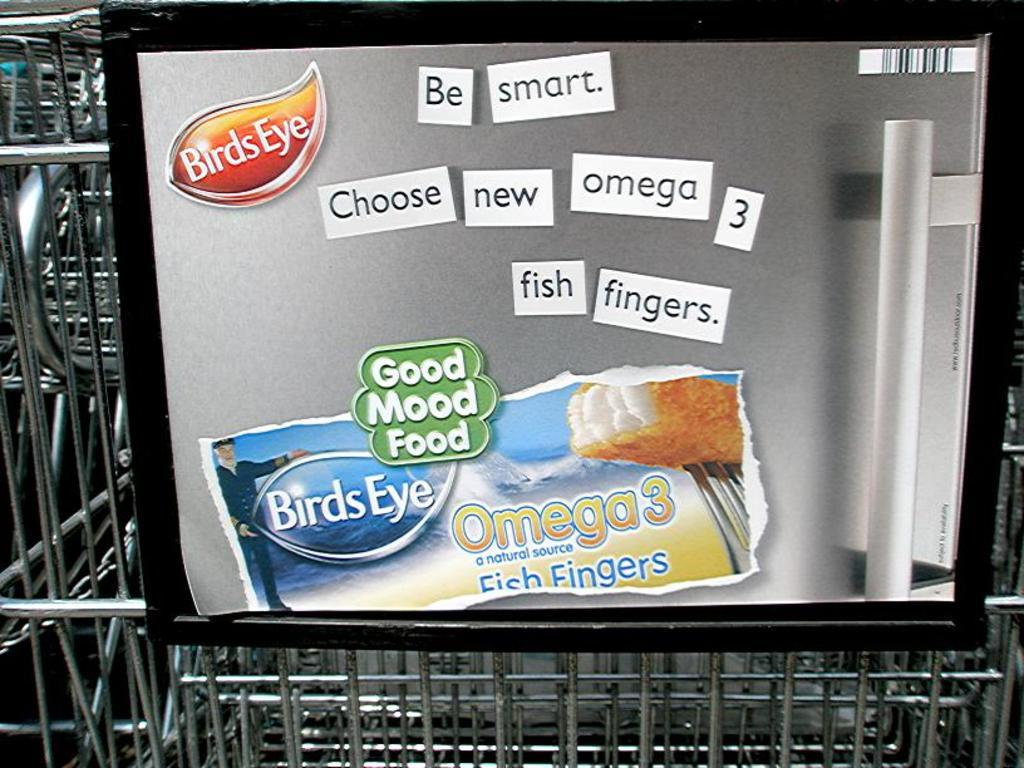<image>
Share a concise interpretation of the image provided. a fridge with some signs on it with one of them that says 'birds eye' 